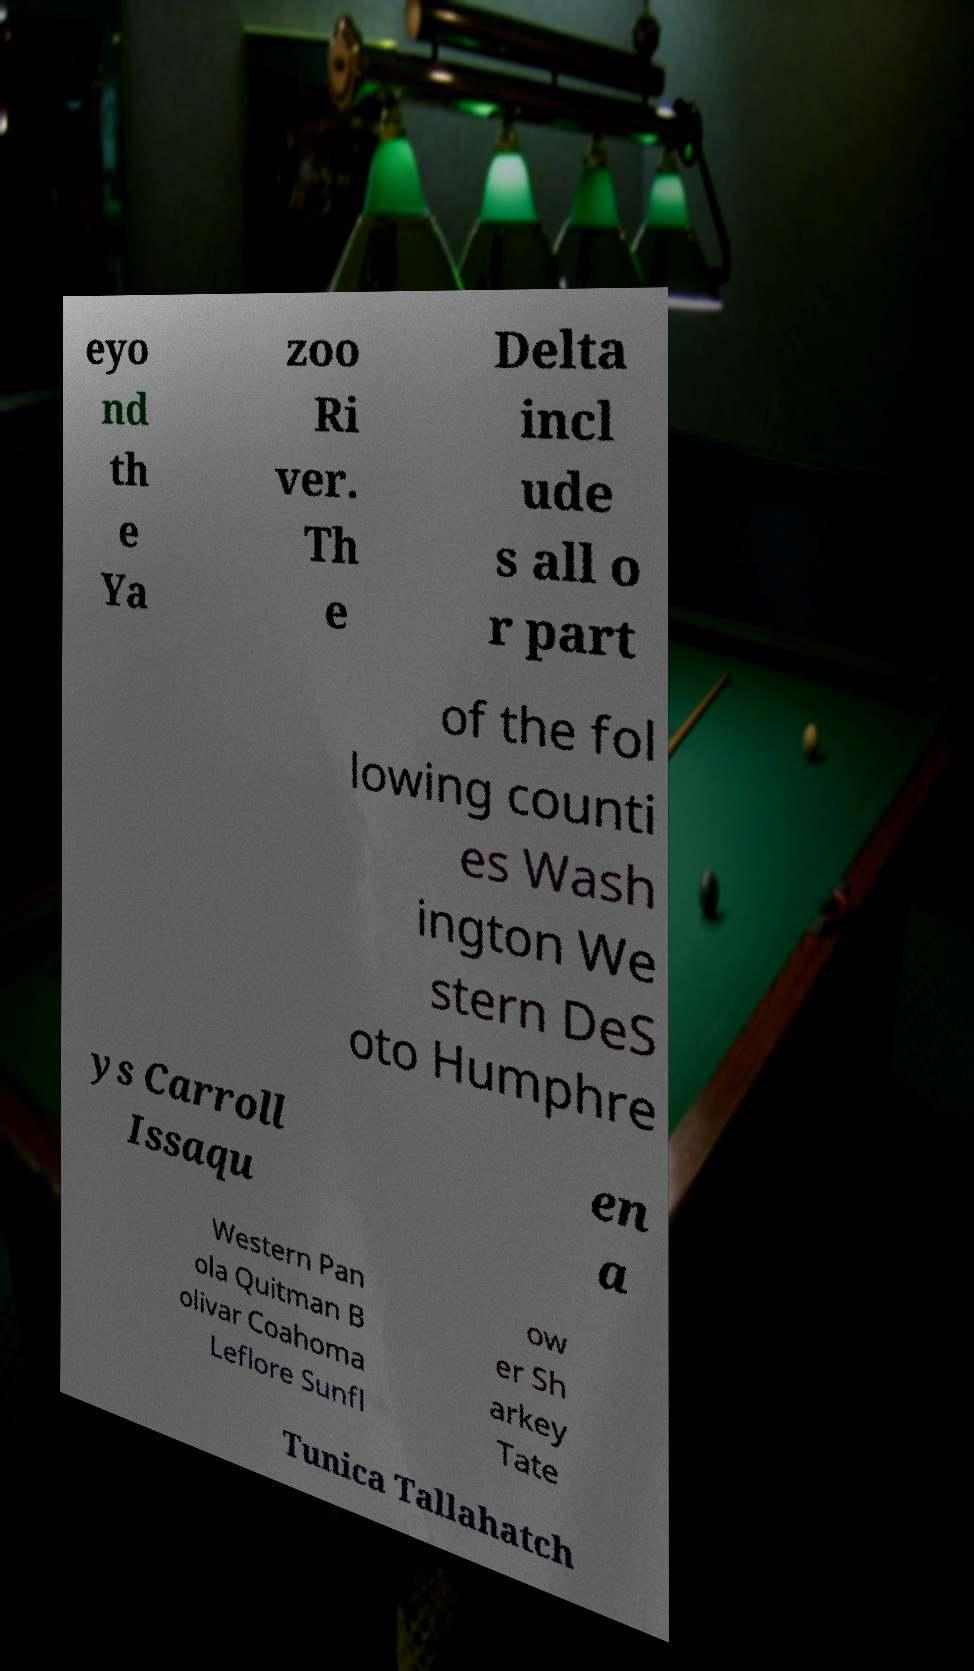Please read and relay the text visible in this image. What does it say? eyo nd th e Ya zoo Ri ver. Th e Delta incl ude s all o r part of the fol lowing counti es Wash ington We stern DeS oto Humphre ys Carroll Issaqu en a Western Pan ola Quitman B olivar Coahoma Leflore Sunfl ow er Sh arkey Tate Tunica Tallahatch 